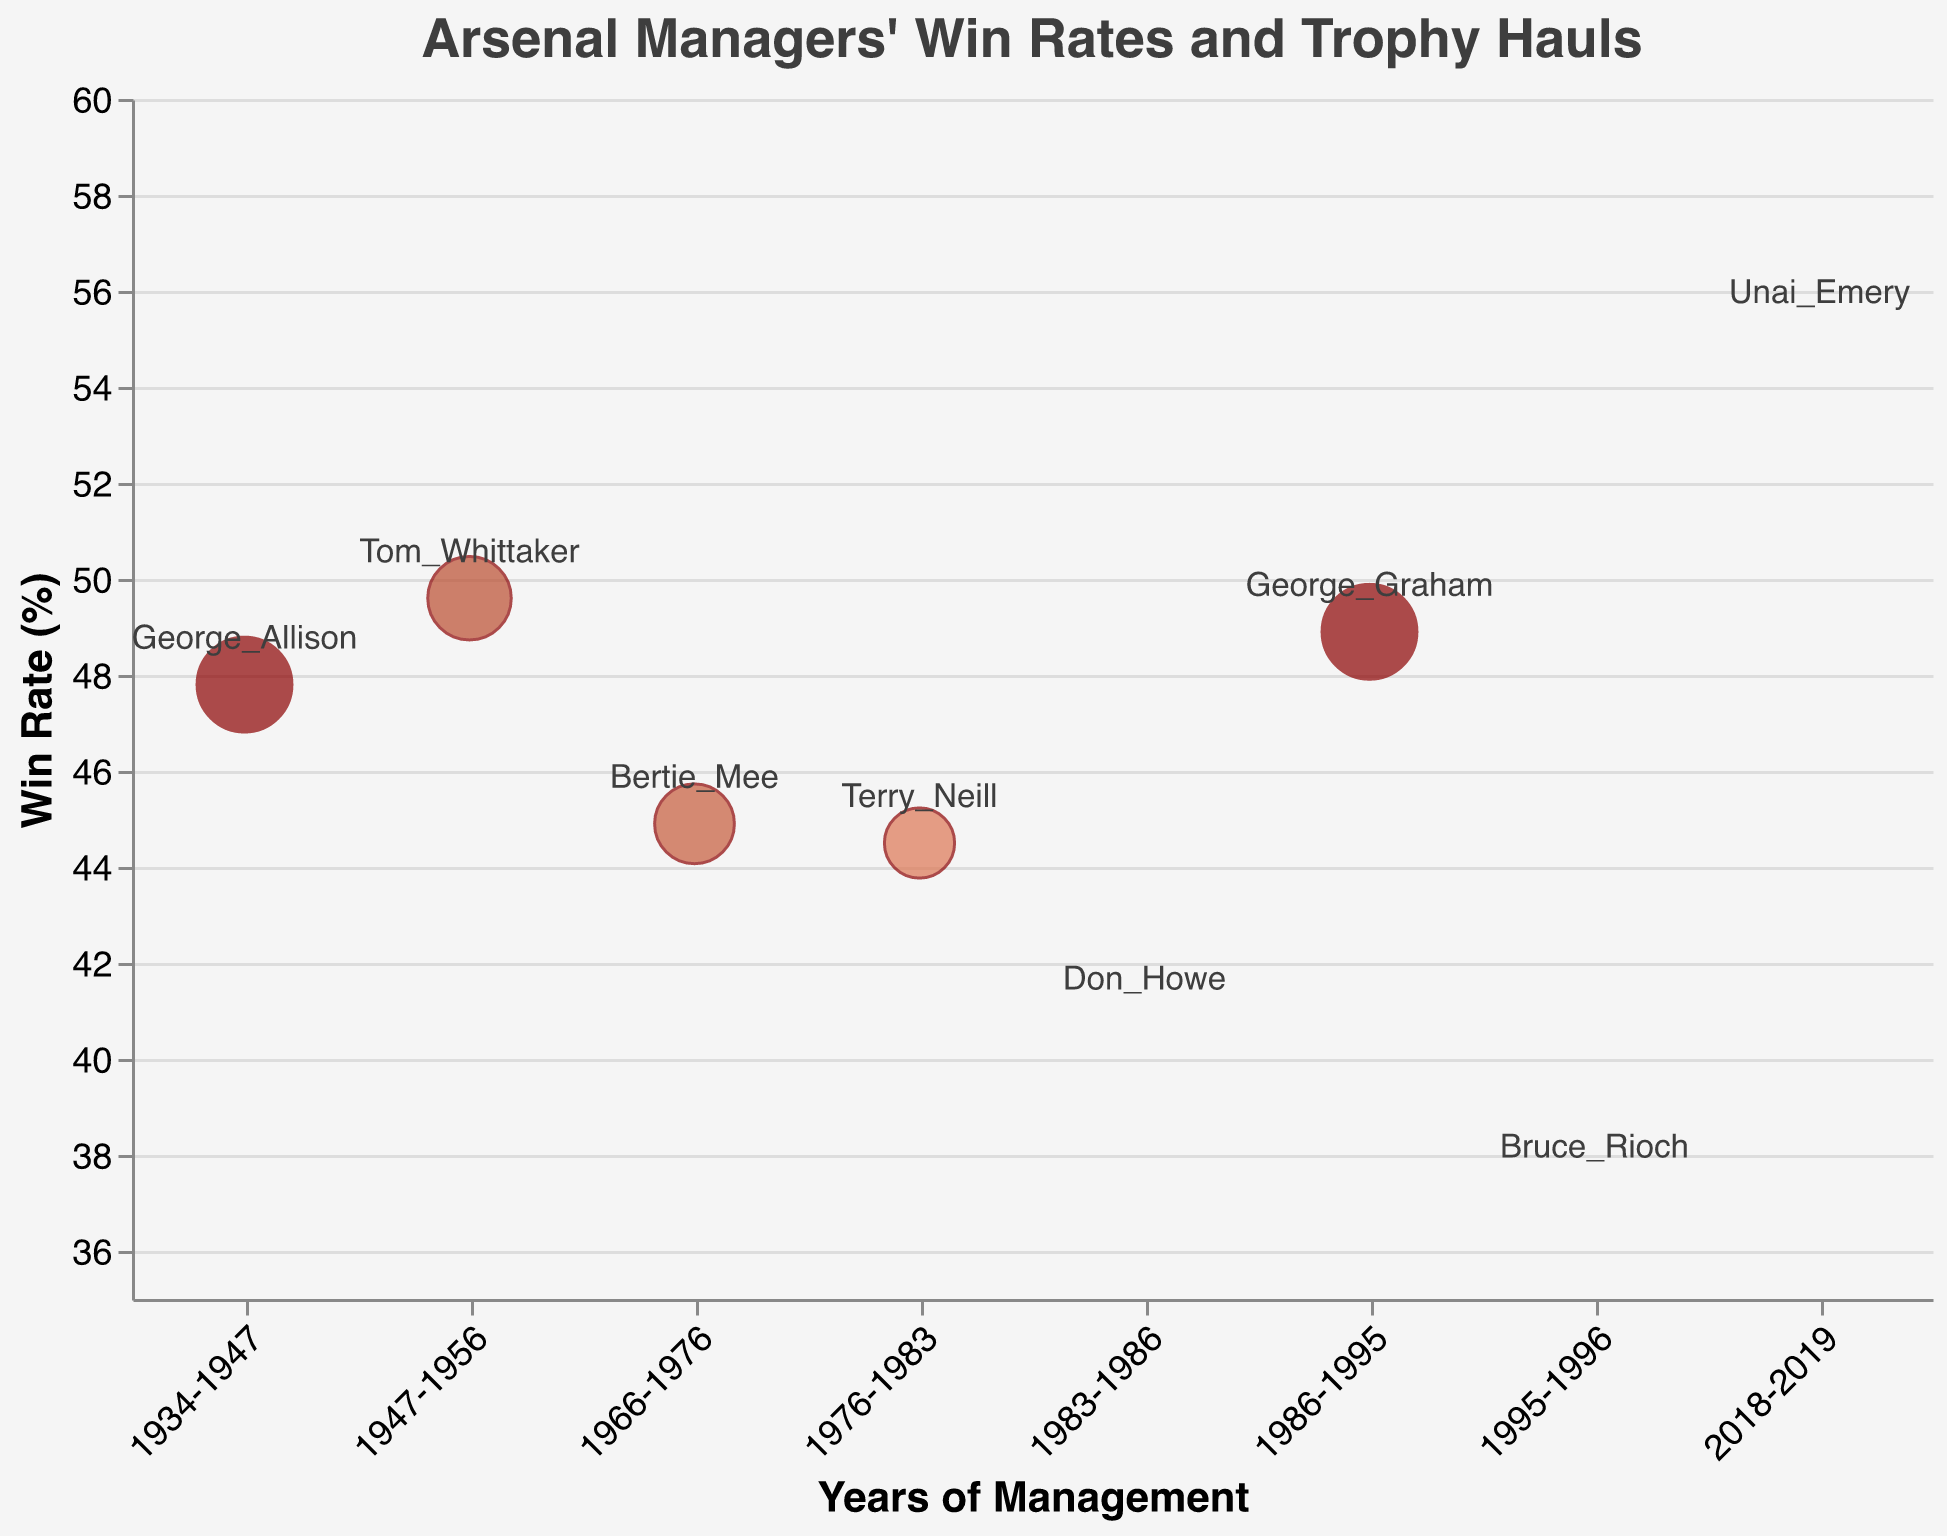What manager has the highest win rate? The manager with the highest win rate will be the data point with the highest value on the y-axis. Unai Emery has the highest win rate of 55.0%.
Answer: Unai Emery Which two managers have the same number of trophy wins? We need to identify two managers that have the same value for trophy wins based on the bubble sizes and colors. George Allison and George Graham both have 10 trophy wins.
Answer: George Allison and George Graham How many trophies did Tom Whittaker win? Find Tom Whittaker's data point and check the trophy wins value in the tooltip or by the bubble size and color. Tom Whittaker has 6 trophy wins.
Answer: 6 Which manager had the lowest win rate? The manager with the lowest win rate will be the data point closest to the bottom of the y-axis. Bruce Rioch has the lowest win rate of 37.2%.
Answer: Bruce Rioch How many managers won zero trophies? Count the number of data points with a "TrophyWins" value of 0 by checking the tooltip information. There are 3 managers with zero trophies: Don Howe, Bruce Rioch, and Unai Emery.
Answer: 3 Which manager's tenure directly followed George Graham's? Look for the years during which George Graham managed (1986-1995) and identify the manager who follows in those years. Bruce Rioch managed in 1995-1996, immediately following George Graham.
Answer: Bruce Rioch Who managed Arsenal during the pre-war period? Find the manager who has the earliest years listed, corresponding to the pre-war period. George Allison managed from 1934-1947, overlapping the pre-war period.
Answer: George Allison Which managers have a win rate between 40-50% and also won at least 3 trophies? Filter the managers within the win rate range of 40-50% and then check their trophy wins. Managers fitting this are George Allison, Tom Whittaker, and Terry Neill.
Answer: George Allison, Tom Whittaker, and Terry Neill 